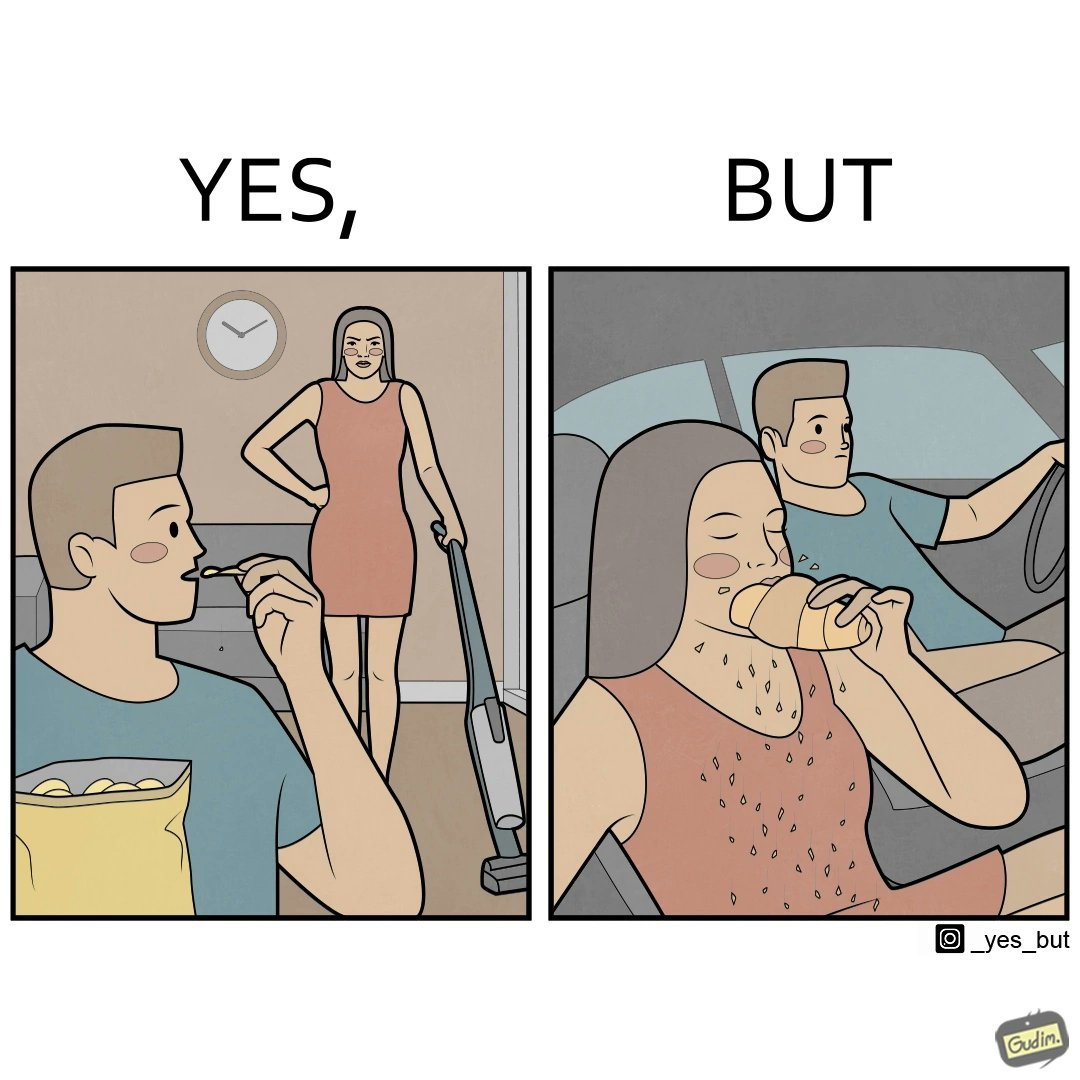Describe what you see in this image. The image is ironic, because in the left image she is seen how sincere she is about keeping her home clean but in the right image she forgets these principles while travelling in the car 